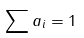<formula> <loc_0><loc_0><loc_500><loc_500>\sum a _ { i } = 1</formula> 